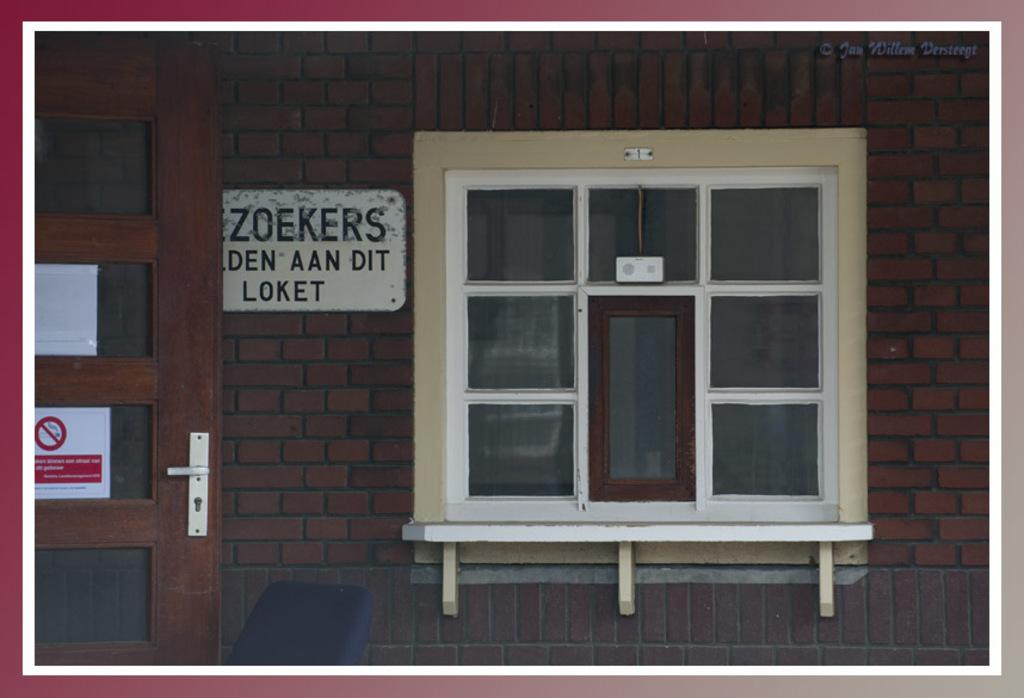What type of structure is visible in the image? There is a brick wall in the image. Are there any openings in the brick wall? Yes, there is a door and a window in the image. What is hanging on the brick wall? There is a poster in the image. What type of credit card is shown in the image? There is no credit card present in the image. What color is the dress hanging on the wall in the image? There is no dress present in the image. 